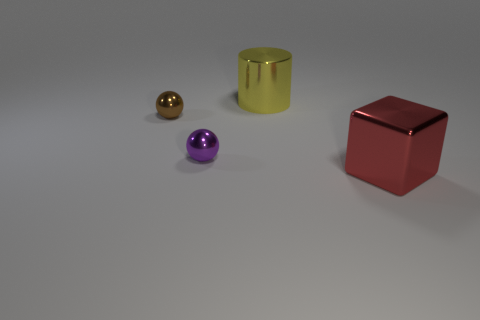How many things are big metal things or tiny metallic objects on the right side of the brown object?
Your response must be concise. 3. Is the number of blocks to the right of the block less than the number of big objects left of the brown sphere?
Offer a terse response. No. What number of other objects are the same material as the small brown sphere?
Offer a very short reply. 3. Does the big thing that is to the left of the red shiny block have the same color as the big cube?
Give a very brief answer. No. Is there a red object that is behind the tiny thing that is on the left side of the small purple thing?
Your answer should be compact. No. There is a thing that is both to the left of the cylinder and in front of the small brown thing; what material is it made of?
Ensure brevity in your answer.  Metal. What shape is the red object that is the same material as the brown thing?
Provide a succinct answer. Cube. Is there any other thing that is the same shape as the red object?
Keep it short and to the point. No. Is the material of the tiny ball that is in front of the brown metallic sphere the same as the yellow thing?
Your answer should be very brief. Yes. What is the small thing that is right of the brown shiny thing made of?
Offer a very short reply. Metal. 